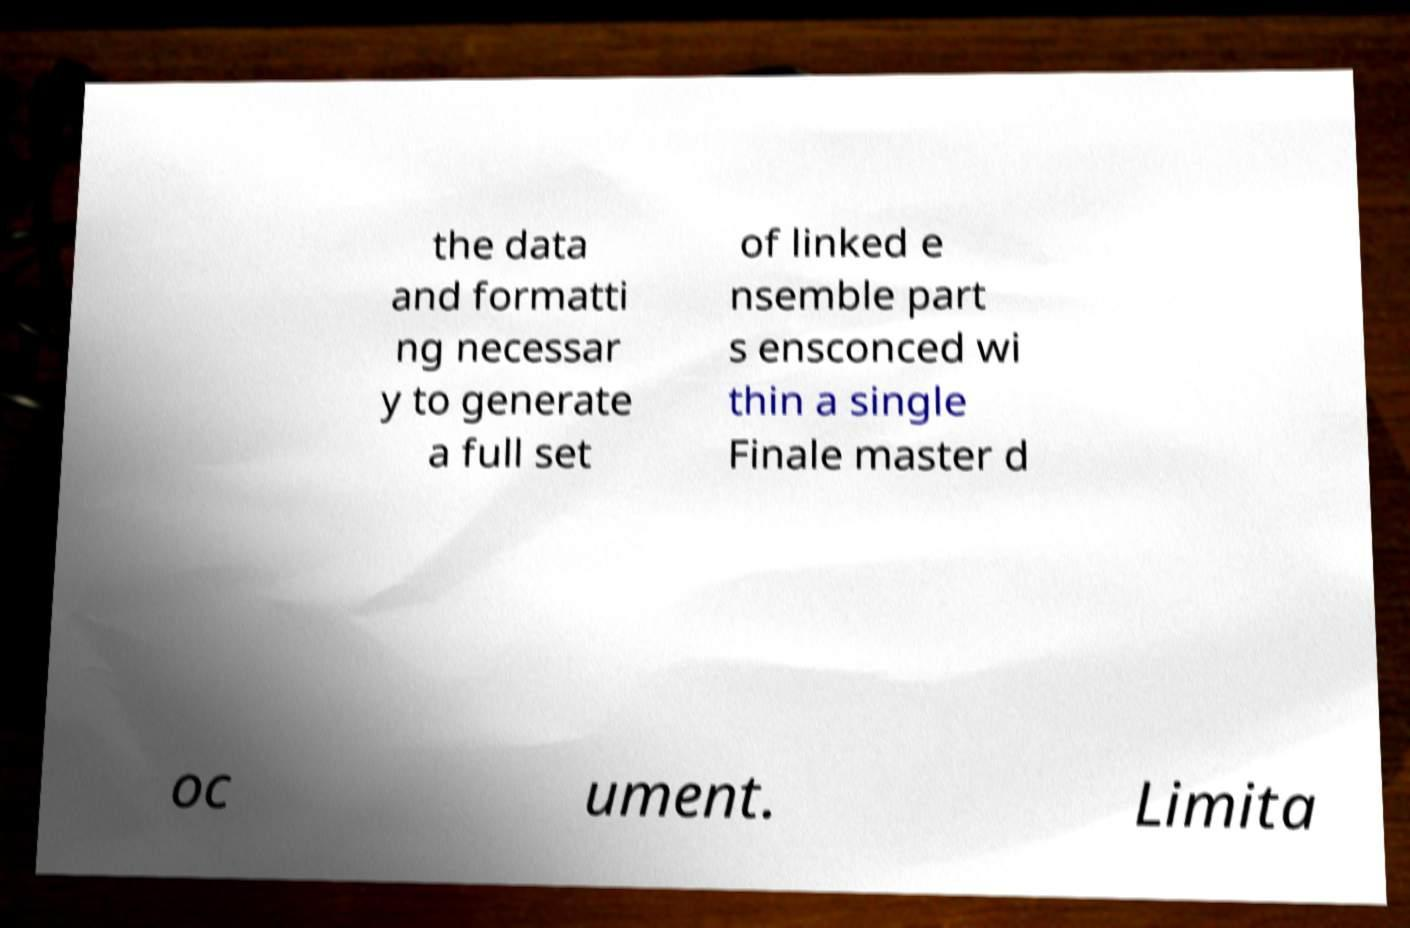There's text embedded in this image that I need extracted. Can you transcribe it verbatim? the data and formatti ng necessar y to generate a full set of linked e nsemble part s ensconced wi thin a single Finale master d oc ument. Limita 